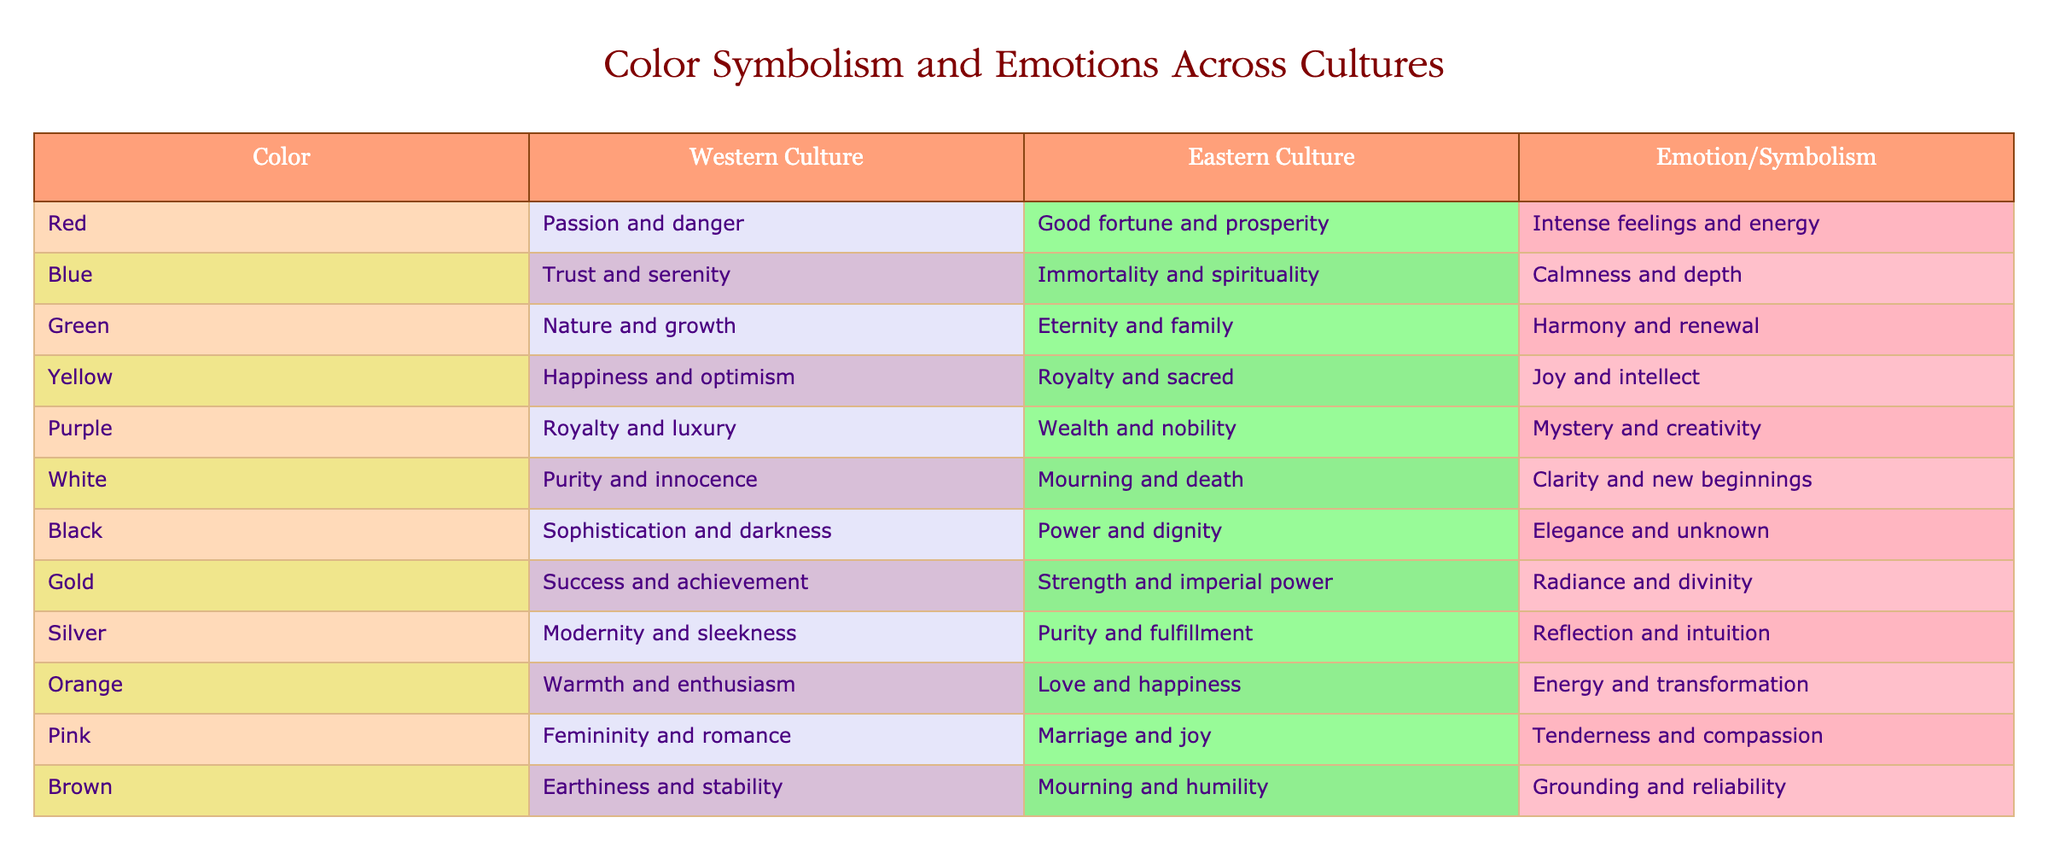What is the emotion associated with the color purple in Western culture? The table shows that in Western culture, the emotion associated with purple is related to royalty and luxury. By simply locating the 'purple' row and reading the corresponding value under 'Western Culture', the answer is obtained.
Answer: Royalty and luxury Which color symbolizes nature and growth in Eastern culture? By examining the 'Eastern Culture' column in the table, it can be identified that the color green symbolizes eternity and family, which is closely linked to nature and growth. Thus, the answer can be found directly from this column.
Answer: Green Is it true that silver is associated with purity and fulfillment in Eastern culture? Looking at the specific row for silver and the corresponding value in the 'Eastern Culture' column shows that the association is indeed with purity and fulfillment. Therefore, the answer is straightforwardly determined.
Answer: Yes What color represents joy and intellect in Eastern culture? Upon checking the 'Eastern Culture' column and searching for the emotion of joy and intellect, one finds that the color yellow corresponds with this emotion. This can be confirmed by locating the relevant row.
Answer: Yellow Which color shares the emotion of wisdom and fear across cultures? Analyzing the table reveals that no specific color corresponds to both wisdom and fear in the emotions listed; hence, the need for this evaluation leads to the conclusion that no such color exists in the table.
Answer: None What is the difference in the associated emotions of red between Western and Eastern cultures? The table displays that in Western culture, red corresponds to passion and danger whereas in Eastern culture it signifies good fortune and prosperity. To find the difference, one can interpret the emotional context which is contrasting in both cultures. Thus, the final evaluation highlights a rich disparity.
Answer: Contrasting emotions How many colors symbolize happiness in both cultures combined? By reviewing the table, it is evident that the colors yellow from both cultures symbolize happiness. This requires searching through the ‘Emotion/Symbolism’ section and confirming relevancy, leading to the inference that happiness is represented in both instances indicated for yellow in respective columns.
Answer: One color What is the average emotion represented by the colors red, blue, and yellow in Western culture? To find the average emotion representation, one inspects Western culture's emotions for red (passion and danger), blue (trust and serenity), and yellow (happiness and optimism). Considering these emotions collectively, one can deduce that they resonate with intense feelings, calmness, and joy, resulting in an overall perspective of vibrant emotions in Western culture.
Answer: Vibrant emotions 